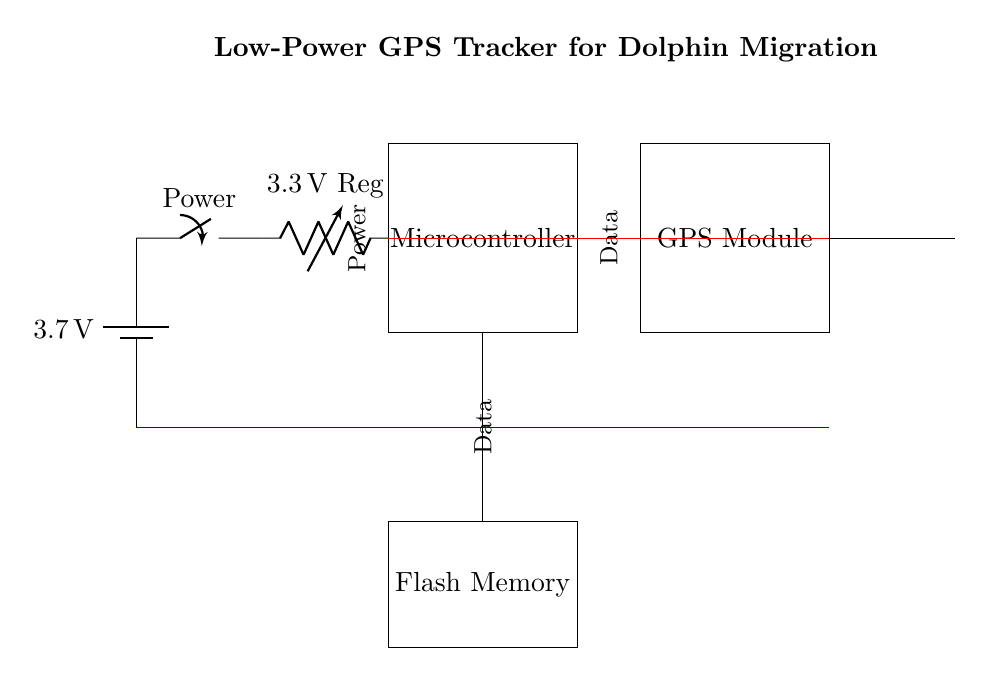what is the voltage supplied by the battery? The circuit shows a battery labeled with a voltage of 3.7 volts, indicating the amount of electrical potential it provides to the circuit.
Answer: 3.7 volts what component regulates the voltage to the microcontroller? The circuit includes a voltage regulator specifically noted as providing 3.3 volts. This indicates that the power from the battery is being adjusted to a lower, stable voltage suitable for the microcontroller.
Answer: 3.3 volts Regulator how many main components are present in this circuit? By counting the labeled components in the circuit diagram, we see a battery, a voltage regulator, a microcontroller, a GPS module, an antenna, and flash memory, which totals to six main components.
Answer: Six components what type of memory is used in this circuit? The circuit has a component labeled as Flash Memory. This indicates the type of storage used for recording data from the GPS module, which is suitable for retaining information without a power supply.
Answer: Flash Memory what is the primary purpose of the circuit? The title of the circuit suggests that its main function is to track dolphin migration using GPS technology, implying the integration of positional tracking capabilities.
Answer: Low-Power GPS Tracker for Dolphin Migration how does data flow from the microcontroller to the GPS module? The diagram shows a direct line connecting the microcontroller to the GPS module, indicating that the microcontroller sends data to the GPS module through this connection, which is necessary for processing location information.
Answer: Direct connection what is the role of the antenna in this circuit? The antenna is used for communicating with satellites or receivers by transmitting and receiving signals from the GPS module. This component ensures that the system can interact with external GPS signals for accurate location tracking.
Answer: Communication with GPS signals 